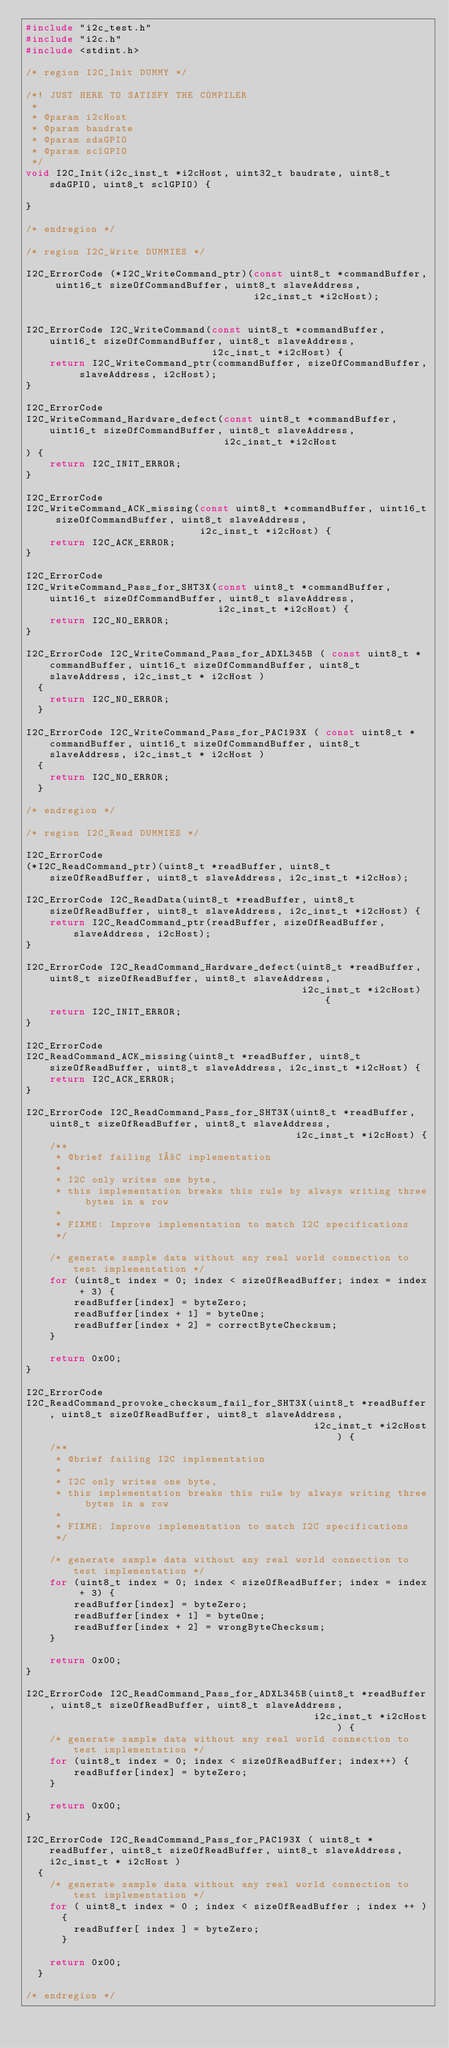Convert code to text. <code><loc_0><loc_0><loc_500><loc_500><_C_>#include "i2c_test.h"
#include "i2c.h"
#include <stdint.h>

/* region I2C_Init DUMMY */

/*! JUST HERE TO SATISFY THE COMPILER
 *
 * @param i2cHost
 * @param baudrate
 * @param sdaGPIO
 * @param sclGPIO
 */
void I2C_Init(i2c_inst_t *i2cHost, uint32_t baudrate, uint8_t sdaGPIO, uint8_t sclGPIO) {

}

/* endregion */

/* region I2C_Write DUMMIES */

I2C_ErrorCode (*I2C_WriteCommand_ptr)(const uint8_t *commandBuffer, uint16_t sizeOfCommandBuffer, uint8_t slaveAddress,
                                      i2c_inst_t *i2cHost);


I2C_ErrorCode I2C_WriteCommand(const uint8_t *commandBuffer, uint16_t sizeOfCommandBuffer, uint8_t slaveAddress,
                               i2c_inst_t *i2cHost) {
    return I2C_WriteCommand_ptr(commandBuffer, sizeOfCommandBuffer, slaveAddress, i2cHost);
}

I2C_ErrorCode
I2C_WriteCommand_Hardware_defect(const uint8_t *commandBuffer, uint16_t sizeOfCommandBuffer, uint8_t slaveAddress,
                                 i2c_inst_t *i2cHost
) {
    return I2C_INIT_ERROR;
}

I2C_ErrorCode
I2C_WriteCommand_ACK_missing(const uint8_t *commandBuffer, uint16_t sizeOfCommandBuffer, uint8_t slaveAddress,
                             i2c_inst_t *i2cHost) {
    return I2C_ACK_ERROR;
}

I2C_ErrorCode
I2C_WriteCommand_Pass_for_SHT3X(const uint8_t *commandBuffer, uint16_t sizeOfCommandBuffer, uint8_t slaveAddress,
                                i2c_inst_t *i2cHost) {
    return I2C_NO_ERROR;
}

I2C_ErrorCode I2C_WriteCommand_Pass_for_ADXL345B ( const uint8_t * commandBuffer, uint16_t sizeOfCommandBuffer, uint8_t slaveAddress, i2c_inst_t * i2cHost )
  {
    return I2C_NO_ERROR;
  }

I2C_ErrorCode I2C_WriteCommand_Pass_for_PAC193X ( const uint8_t * commandBuffer, uint16_t sizeOfCommandBuffer, uint8_t slaveAddress, i2c_inst_t * i2cHost )
  {
    return I2C_NO_ERROR;
  }

/* endregion */

/* region I2C_Read DUMMIES */

I2C_ErrorCode
(*I2C_ReadCommand_ptr)(uint8_t *readBuffer, uint8_t sizeOfReadBuffer, uint8_t slaveAddress, i2c_inst_t *i2cHos);

I2C_ErrorCode I2C_ReadData(uint8_t *readBuffer, uint8_t sizeOfReadBuffer, uint8_t slaveAddress, i2c_inst_t *i2cHost) {
    return I2C_ReadCommand_ptr(readBuffer, sizeOfReadBuffer, slaveAddress, i2cHost);
}

I2C_ErrorCode I2C_ReadCommand_Hardware_defect(uint8_t *readBuffer, uint8_t sizeOfReadBuffer, uint8_t slaveAddress,
                                              i2c_inst_t *i2cHost) {
    return I2C_INIT_ERROR;
}

I2C_ErrorCode
I2C_ReadCommand_ACK_missing(uint8_t *readBuffer, uint8_t sizeOfReadBuffer, uint8_t slaveAddress, i2c_inst_t *i2cHost) {
    return I2C_ACK_ERROR;
}

I2C_ErrorCode I2C_ReadCommand_Pass_for_SHT3X(uint8_t *readBuffer, uint8_t sizeOfReadBuffer, uint8_t slaveAddress,
                                             i2c_inst_t *i2cHost) {
    /**
     * @brief failing I²C implementation
     *
     * I2C only writes one byte,
     * this implementation breaks this rule by always writing three bytes in a row
     *
     * FIXME: Improve implementation to match I2C specifications
     */

    /* generate sample data without any real world connection to test implementation */
    for (uint8_t index = 0; index < sizeOfReadBuffer; index = index + 3) {
        readBuffer[index] = byteZero;
        readBuffer[index + 1] = byteOne;
        readBuffer[index + 2] = correctByteChecksum;
    }

    return 0x00;
}

I2C_ErrorCode
I2C_ReadCommand_provoke_checksum_fail_for_SHT3X(uint8_t *readBuffer, uint8_t sizeOfReadBuffer, uint8_t slaveAddress,
                                                i2c_inst_t *i2cHost) {
    /**
     * @brief failing I2C implementation
     *
     * I2C only writes one byte,
     * this implementation breaks this rule by always writing three bytes in a row
     *
     * FIXME: Improve implementation to match I2C specifications
     */

    /* generate sample data without any real world connection to test implementation */
    for (uint8_t index = 0; index < sizeOfReadBuffer; index = index + 3) {
        readBuffer[index] = byteZero;
        readBuffer[index + 1] = byteOne;
        readBuffer[index + 2] = wrongByteChecksum;
    }

    return 0x00;
}

I2C_ErrorCode I2C_ReadCommand_Pass_for_ADXL345B(uint8_t *readBuffer, uint8_t sizeOfReadBuffer, uint8_t slaveAddress,
                                                i2c_inst_t *i2cHost) {
    /* generate sample data without any real world connection to test implementation */
    for (uint8_t index = 0; index < sizeOfReadBuffer; index++) {
        readBuffer[index] = byteZero;
    }

    return 0x00;
}

I2C_ErrorCode I2C_ReadCommand_Pass_for_PAC193X ( uint8_t * readBuffer, uint8_t sizeOfReadBuffer, uint8_t slaveAddress, i2c_inst_t * i2cHost )
  {
    /* generate sample data without any real world connection to test implementation */
    for ( uint8_t index = 0 ; index < sizeOfReadBuffer ; index ++ )
      {
        readBuffer[ index ] = byteZero;
      }
    
    return 0x00;
  }
  
/* endregion */
  </code> 